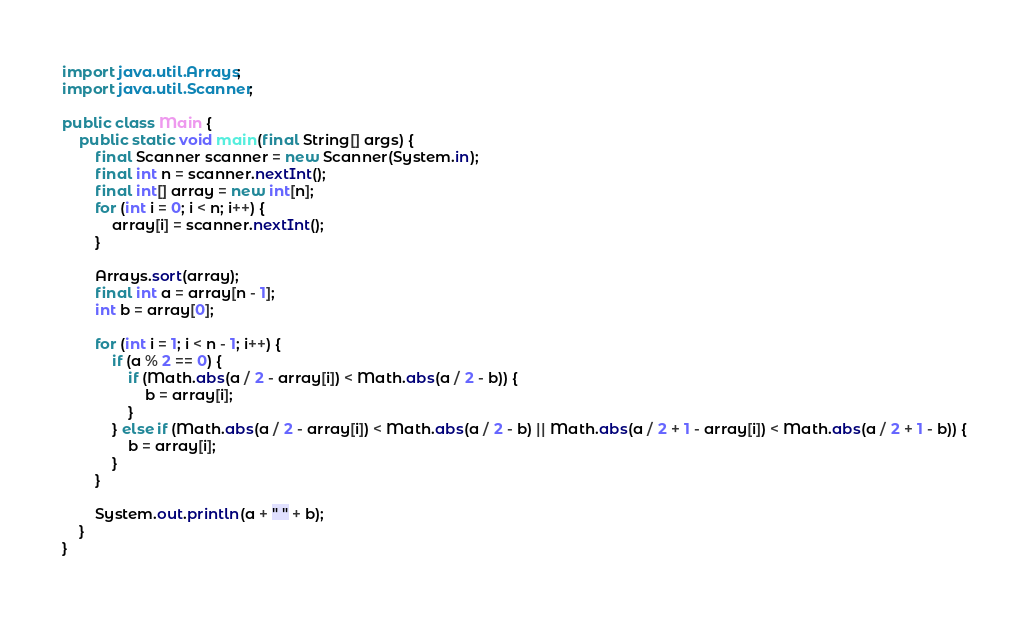Convert code to text. <code><loc_0><loc_0><loc_500><loc_500><_Java_>
import java.util.Arrays;
import java.util.Scanner;

public class Main {
    public static void main(final String[] args) {
        final Scanner scanner = new Scanner(System.in);
        final int n = scanner.nextInt();
        final int[] array = new int[n];
        for (int i = 0; i < n; i++) {
            array[i] = scanner.nextInt();
        }

        Arrays.sort(array);
        final int a = array[n - 1];
        int b = array[0];

        for (int i = 1; i < n - 1; i++) {
            if (a % 2 == 0) {
                if (Math.abs(a / 2 - array[i]) < Math.abs(a / 2 - b)) {
                    b = array[i];
                }
            } else if (Math.abs(a / 2 - array[i]) < Math.abs(a / 2 - b) || Math.abs(a / 2 + 1 - array[i]) < Math.abs(a / 2 + 1 - b)) {
                b = array[i];
            }
        }

        System.out.println(a + " " + b);
    }
}
</code> 